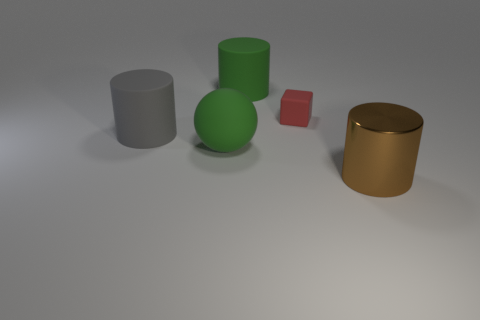There is a big matte cylinder behind the cube; is it the same color as the matte sphere?
Ensure brevity in your answer.  Yes. What size is the cylinder that is both right of the sphere and on the left side of the brown thing?
Provide a succinct answer. Large. What number of large objects are either brown shiny cylinders or gray things?
Your response must be concise. 2. There is a large green rubber object in front of the cube; what is its shape?
Ensure brevity in your answer.  Sphere. What number of big metal objects are there?
Provide a short and direct response. 1. Do the red object and the large green ball have the same material?
Offer a terse response. Yes. Are there more gray objects that are on the right side of the large brown cylinder than large purple cubes?
Offer a terse response. No. How many things are either tiny yellow metal objects or big cylinders that are on the left side of the shiny object?
Provide a succinct answer. 2. Are there more big green objects that are right of the small thing than green cylinders in front of the large green cylinder?
Give a very brief answer. No. What material is the big cylinder that is in front of the rubber cylinder left of the green matte thing to the right of the large green sphere made of?
Offer a terse response. Metal. 